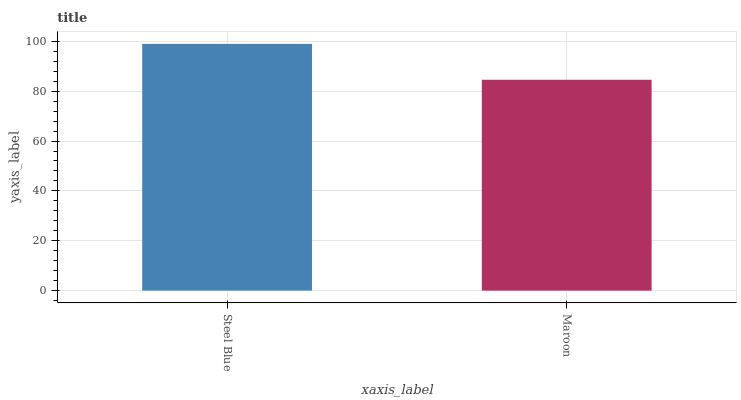Is Maroon the maximum?
Answer yes or no. No. Is Steel Blue greater than Maroon?
Answer yes or no. Yes. Is Maroon less than Steel Blue?
Answer yes or no. Yes. Is Maroon greater than Steel Blue?
Answer yes or no. No. Is Steel Blue less than Maroon?
Answer yes or no. No. Is Steel Blue the high median?
Answer yes or no. Yes. Is Maroon the low median?
Answer yes or no. Yes. Is Maroon the high median?
Answer yes or no. No. Is Steel Blue the low median?
Answer yes or no. No. 